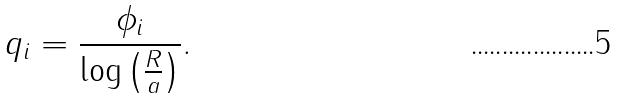Convert formula to latex. <formula><loc_0><loc_0><loc_500><loc_500>q _ { i } = \frac { \phi _ { i } } { \log \left ( \frac { R } { a } \right ) } .</formula> 